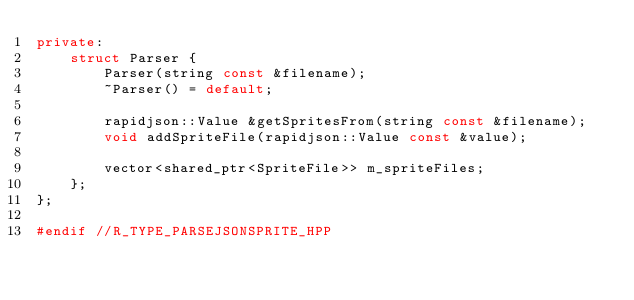Convert code to text. <code><loc_0><loc_0><loc_500><loc_500><_C++_>private:
    struct Parser {
        Parser(string const &filename);
        ~Parser() = default;

        rapidjson::Value &getSpritesFrom(string const &filename);
        void addSpriteFile(rapidjson::Value const &value);

        vector<shared_ptr<SpriteFile>> m_spriteFiles;
    };
};

#endif //R_TYPE_PARSEJSONSPRITE_HPP
</code> 